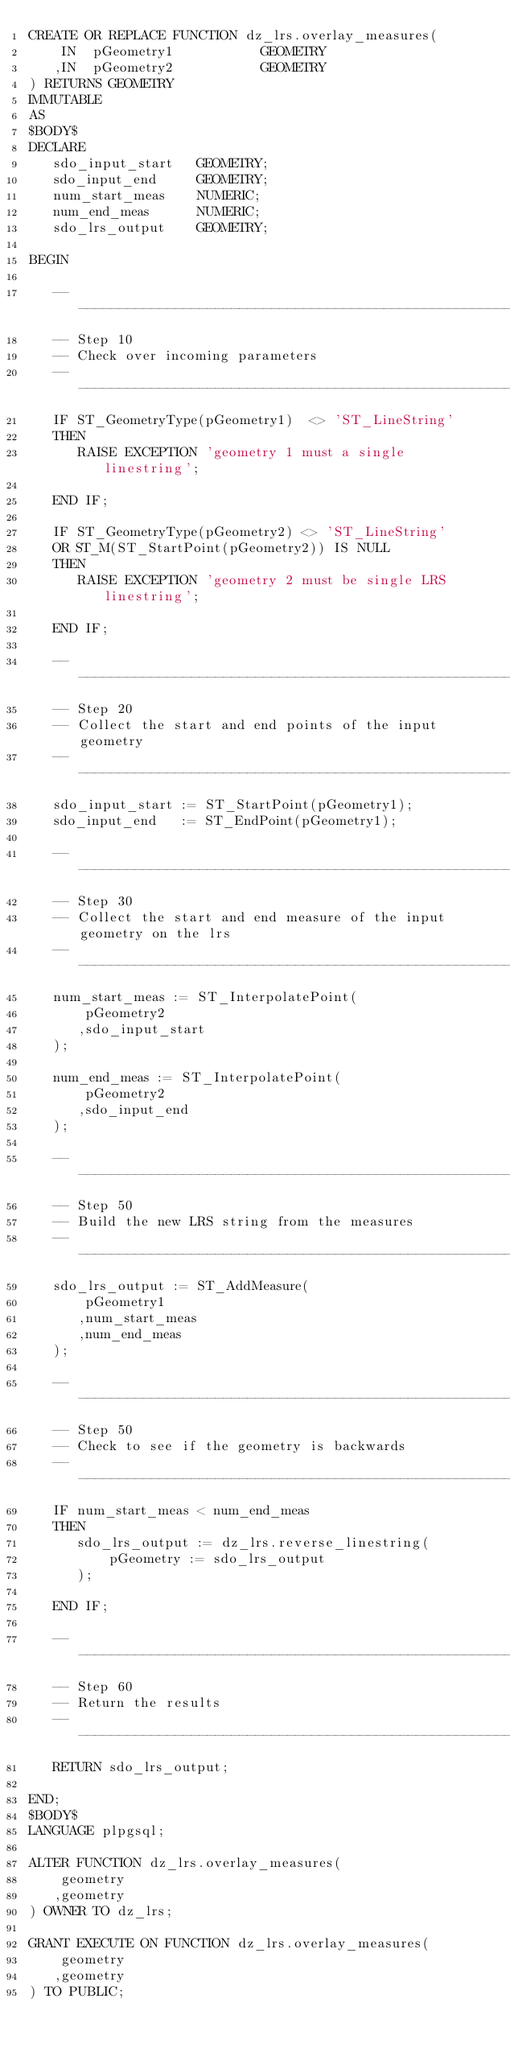<code> <loc_0><loc_0><loc_500><loc_500><_SQL_>CREATE OR REPLACE FUNCTION dz_lrs.overlay_measures(
    IN  pGeometry1           GEOMETRY
   ,IN  pGeometry2           GEOMETRY
) RETURNS GEOMETRY
IMMUTABLE
AS
$BODY$ 
DECLARE
   sdo_input_start   GEOMETRY;
   sdo_input_end     GEOMETRY;
   num_start_meas    NUMERIC;
   num_end_meas      NUMERIC;
   sdo_lrs_output    GEOMETRY;
   
BEGIN

   ----------------------------------------------------------------------------
   -- Step 10
   -- Check over incoming parameters
   ----------------------------------------------------------------------------
   IF ST_GeometryType(pGeometry1)  <> 'ST_LineString'
   THEN
      RAISE EXCEPTION 'geometry 1 must a single linestring';
      
   END IF;
   
   IF ST_GeometryType(pGeometry2) <> 'ST_LineString'
   OR ST_M(ST_StartPoint(pGeometry2)) IS NULL
   THEN
      RAISE EXCEPTION 'geometry 2 must be single LRS linestring';
      
   END IF;
   
   --------------------------------------------------------------------------
   -- Step 20
   -- Collect the start and end points of the input geometry
   --------------------------------------------------------------------------
   sdo_input_start := ST_StartPoint(pGeometry1);
   sdo_input_end   := ST_EndPoint(pGeometry1);
   
   --------------------------------------------------------------------------
   -- Step 30
   -- Collect the start and end measure of the input geometry on the lrs
   --------------------------------------------------------------------------
   num_start_meas := ST_InterpolatePoint(
       pGeometry2
      ,sdo_input_start
   );
      
   num_end_meas := ST_InterpolatePoint(
       pGeometry2
      ,sdo_input_end
   );
   
   --------------------------------------------------------------------------
   -- Step 50
   -- Build the new LRS string from the measures
   --------------------------------------------------------------------------
   sdo_lrs_output := ST_AddMeasure(
       pGeometry1
      ,num_start_meas
      ,num_end_meas
   );
   
   --------------------------------------------------------------------------
   -- Step 50
   -- Check to see if the geometry is backwards
   --------------------------------------------------------------------------
   IF num_start_meas < num_end_meas
   THEN
      sdo_lrs_output := dz_lrs.reverse_linestring(
          pGeometry := sdo_lrs_output
      );
      
   END IF;

   --------------------------------------------------------------------------
   -- Step 60
   -- Return the results
   --------------------------------------------------------------------------
   RETURN sdo_lrs_output;
   
END;
$BODY$
LANGUAGE plpgsql;

ALTER FUNCTION dz_lrs.overlay_measures(
    geometry
   ,geometry
) OWNER TO dz_lrs;

GRANT EXECUTE ON FUNCTION dz_lrs.overlay_measures(
    geometry
   ,geometry
) TO PUBLIC;

</code> 